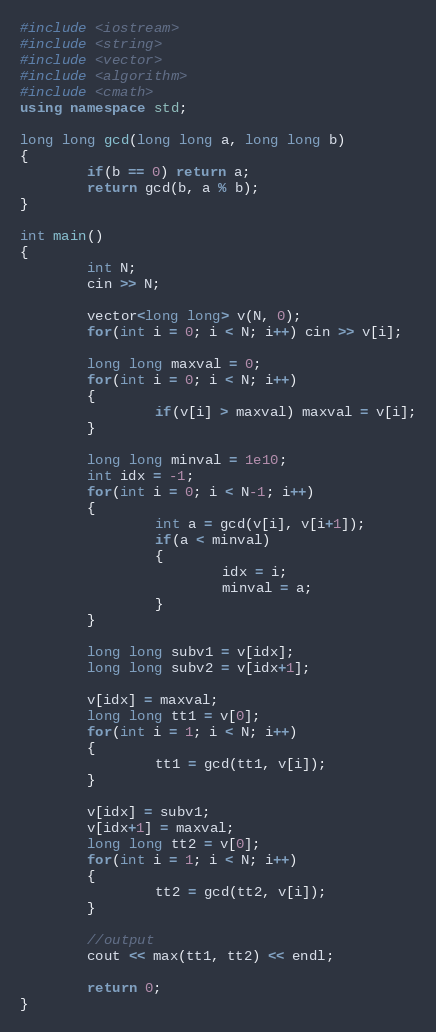Convert code to text. <code><loc_0><loc_0><loc_500><loc_500><_C++_>#include <iostream>
#include <string>
#include <vector>
#include <algorithm>
#include <cmath>
using namespace std;

long long gcd(long long a, long long b)
{
        if(b == 0) return a;
        return gcd(b, a % b);
}

int main()
{
        int N;
        cin >> N;

        vector<long long> v(N, 0);
        for(int i = 0; i < N; i++) cin >> v[i];

        long long maxval = 0;
        for(int i = 0; i < N; i++)
        {
                if(v[i] > maxval) maxval = v[i];
        }

        long long minval = 1e10;
        int idx = -1;
        for(int i = 0; i < N-1; i++)
        {
                int a = gcd(v[i], v[i+1]);
                if(a < minval)
                {
                        idx = i;
                        minval = a;
                }
        }

        long long subv1 = v[idx];
        long long subv2 = v[idx+1];

        v[idx] = maxval;
        long long tt1 = v[0];
        for(int i = 1; i < N; i++)
        {
                tt1 = gcd(tt1, v[i]);
        }

        v[idx] = subv1;
        v[idx+1] = maxval;
        long long tt2 = v[0];
        for(int i = 1; i < N; i++)
        {
                tt2 = gcd(tt2, v[i]);
        }

        //output
        cout << max(tt1, tt2) << endl;

        return 0;
}</code> 